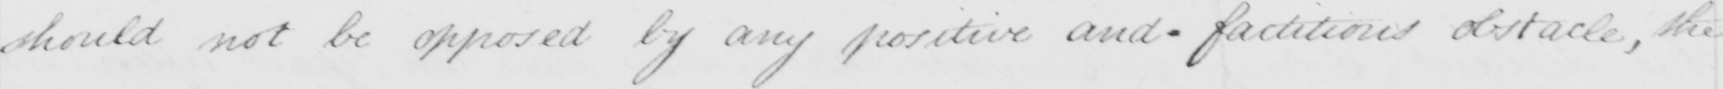Can you read and transcribe this handwriting? should not be opposed by any positive and_factitious obstacle, the 